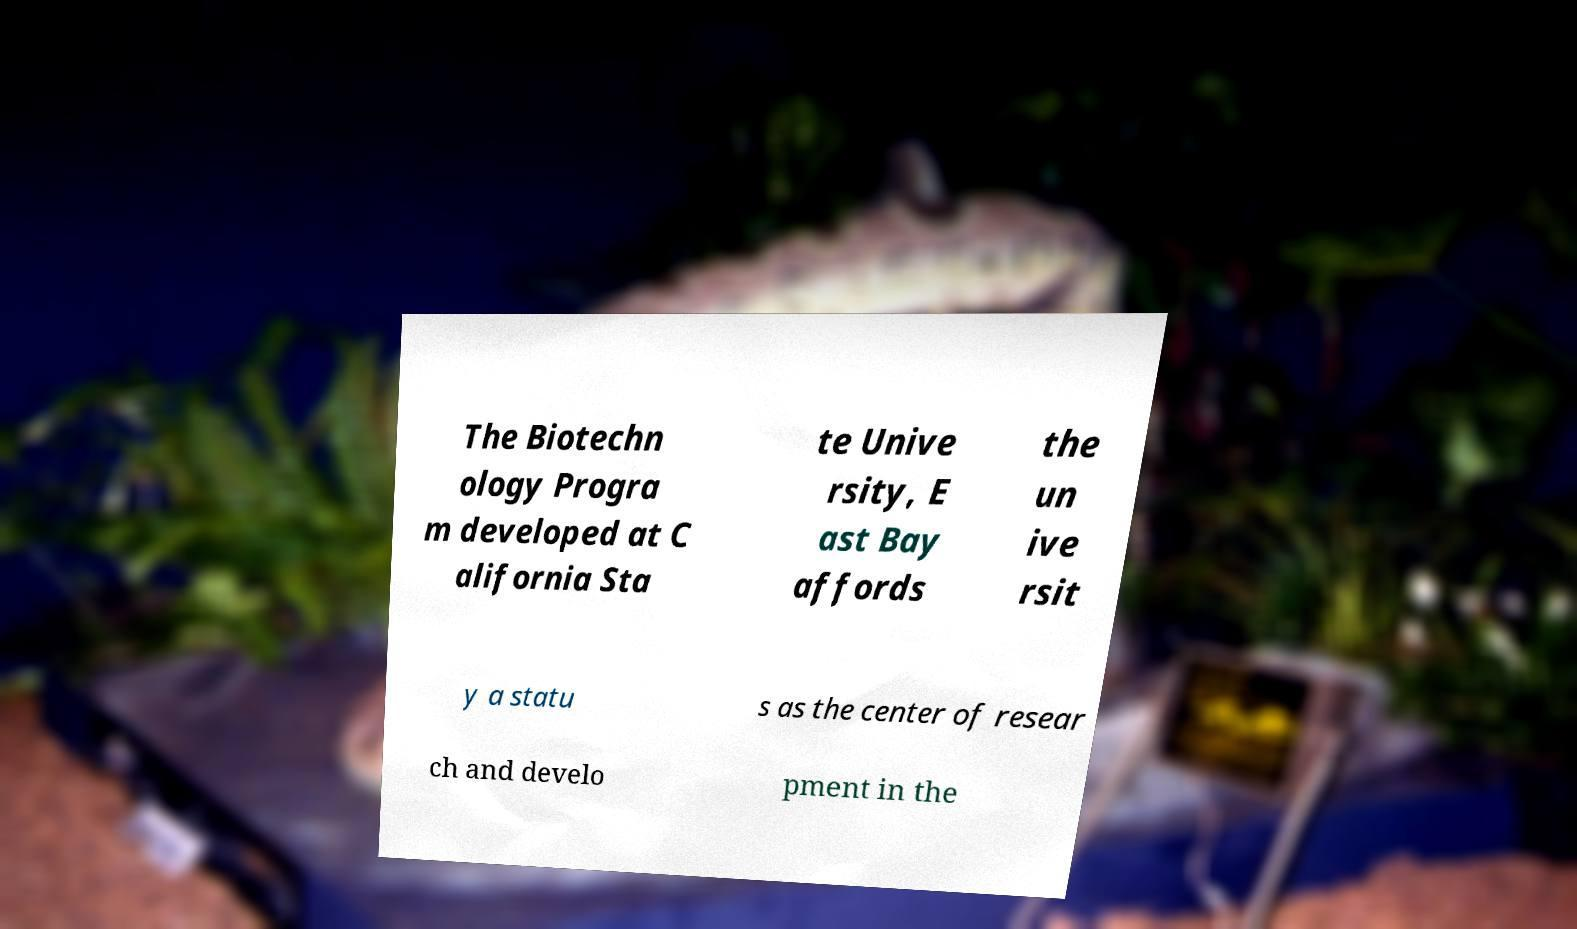For documentation purposes, I need the text within this image transcribed. Could you provide that? The Biotechn ology Progra m developed at C alifornia Sta te Unive rsity, E ast Bay affords the un ive rsit y a statu s as the center of resear ch and develo pment in the 